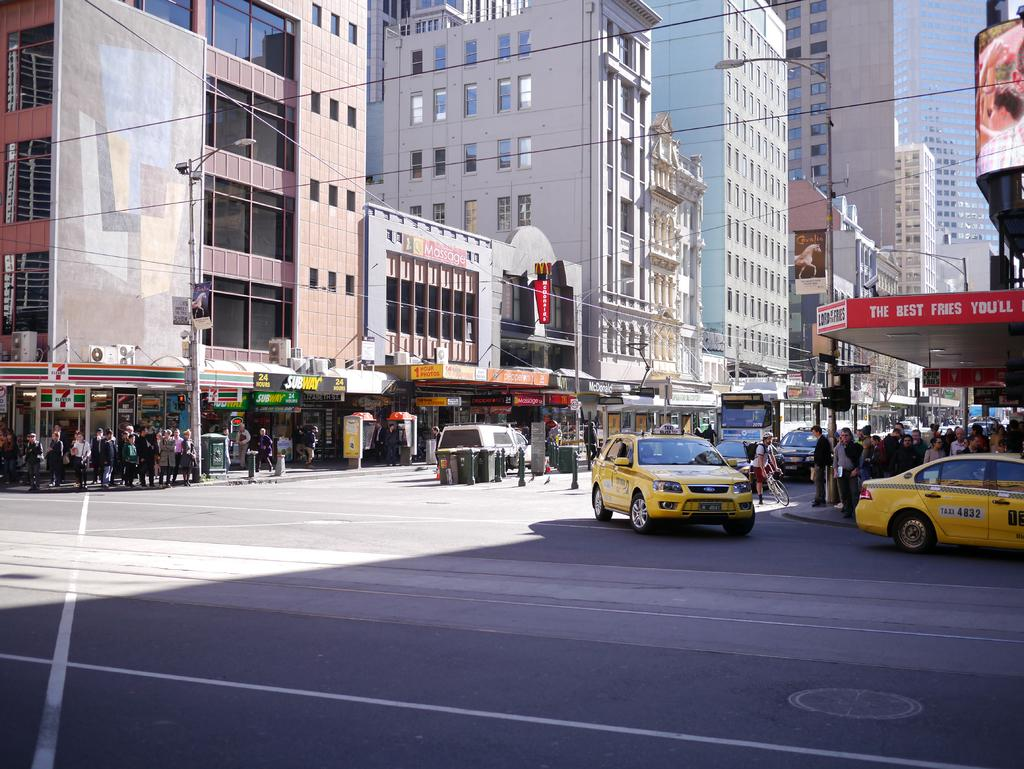Provide a one-sentence caption for the provided image. A store called Lord of the Fries is on the corner with some Taxis in front of it. 